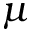<formula> <loc_0><loc_0><loc_500><loc_500>\mu</formula> 